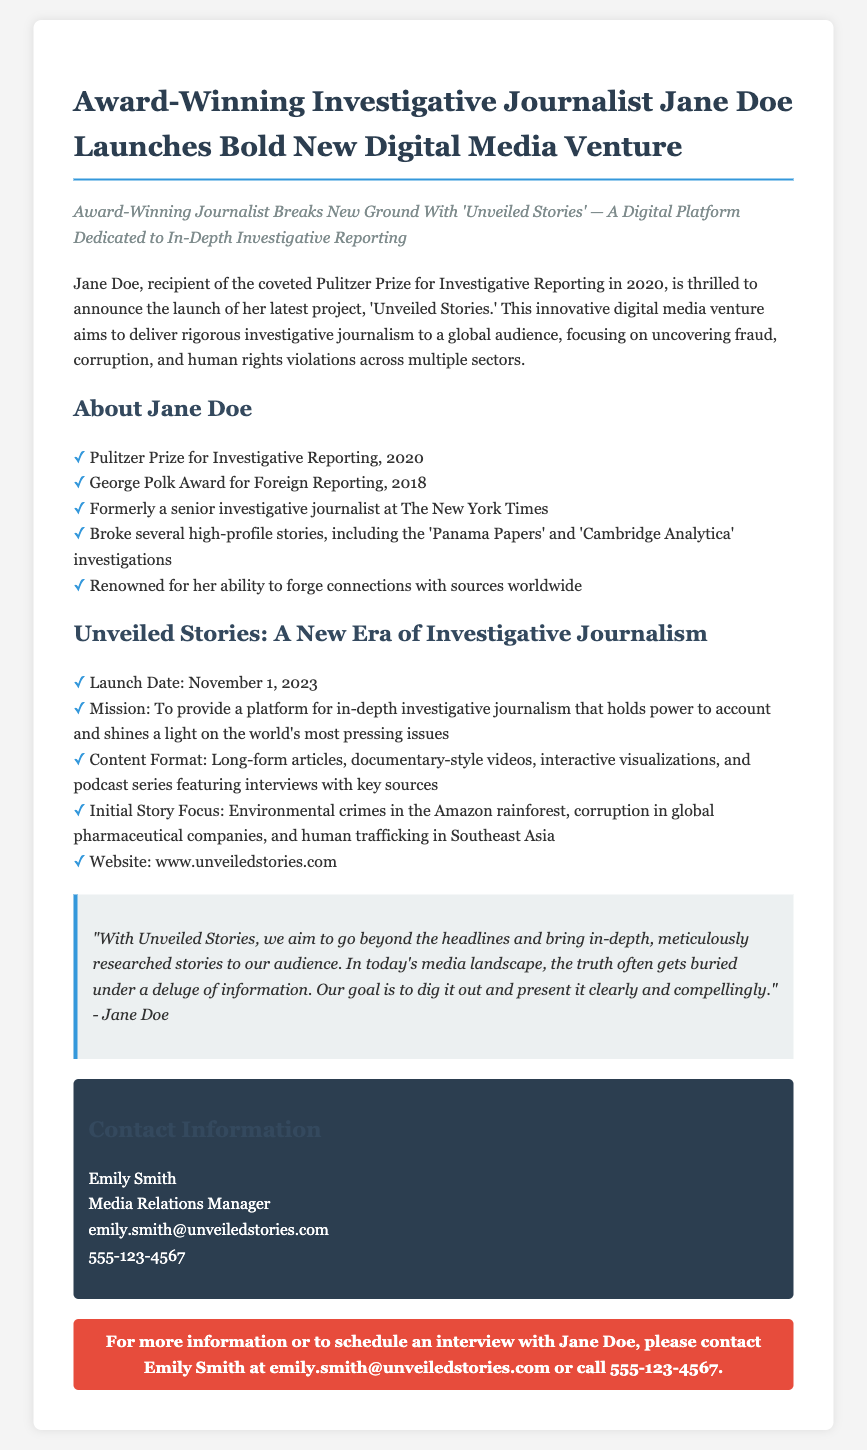What is the name of the new digital media venture? The name of the new digital media venture launched by Jane Doe is 'Unveiled Stories.'
Answer: 'Unveiled Stories' What award did Jane Doe receive in 2020? Jane Doe received the Pulitzer Prize for Investigative Reporting in 2020.
Answer: Pulitzer Prize What was Jane Doe's previous position? Jane Doe was formerly a senior investigative journalist at The New York Times.
Answer: Senior investigative journalist When is the launch date of Unveiled Stories? The launch date of Unveiled Stories is November 1, 2023.
Answer: November 1, 2023 What is the initial story focus of Unveiled Stories? The initial story focus includes environmental crimes in the Amazon rainforest, corruption in global pharmaceutical companies, and human trafficking in Southeast Asia.
Answer: Environmental crimes, corruption, human trafficking What is stated as a mission for Unveiled Stories? The mission is to provide a platform for in-depth investigative journalism that holds power to account and shines a light on the world's most pressing issues.
Answer: To provide a platform for in-depth investigative journalism Who is the Media Relations Manager? The Media Relations Manager mentioned in the press release is Emily Smith.
Answer: Emily Smith What type of content will Unveiled Stories include? Unveiled Stories will include long-form articles, documentary-style videos, interactive visualizations, and podcast series.
Answer: Long-form articles, videos, visualizations, podcasts What is the primary goal of Unveiled Stories mentioned in the quote? The primary goal is to dig out the truth and present it clearly and compellingly.
Answer: Dig out the truth and present it clearly 